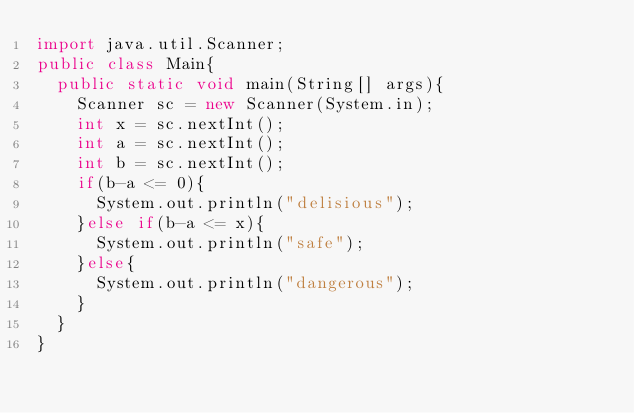Convert code to text. <code><loc_0><loc_0><loc_500><loc_500><_Java_>import java.util.Scanner;
public class Main{
  public static void main(String[] args){
    Scanner sc = new Scanner(System.in);
    int x = sc.nextInt();
    int a = sc.nextInt();
    int b = sc.nextInt();
    if(b-a <= 0){
      System.out.println("delisious");
    }else if(b-a <= x){
      System.out.println("safe");
    }else{
      System.out.println("dangerous");
    }
  }
}</code> 